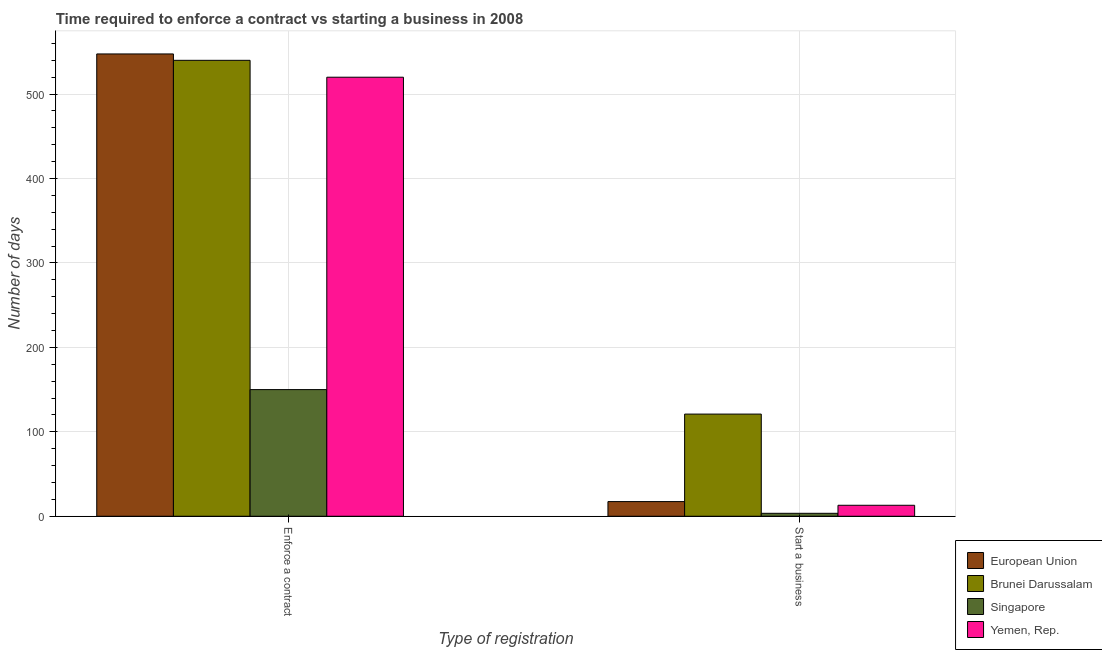How many groups of bars are there?
Keep it short and to the point. 2. Are the number of bars per tick equal to the number of legend labels?
Keep it short and to the point. Yes. What is the label of the 2nd group of bars from the left?
Your answer should be very brief. Start a business. What is the number of days to start a business in European Union?
Your answer should be very brief. 17.37. Across all countries, what is the maximum number of days to enforece a contract?
Ensure brevity in your answer.  547.56. Across all countries, what is the minimum number of days to enforece a contract?
Ensure brevity in your answer.  150. In which country was the number of days to start a business maximum?
Your response must be concise. Brunei Darussalam. In which country was the number of days to start a business minimum?
Give a very brief answer. Singapore. What is the total number of days to start a business in the graph?
Keep it short and to the point. 154.87. What is the difference between the number of days to start a business in European Union and the number of days to enforece a contract in Brunei Darussalam?
Keep it short and to the point. -522.63. What is the average number of days to enforece a contract per country?
Make the answer very short. 439.39. What is the difference between the number of days to enforece a contract and number of days to start a business in European Union?
Your answer should be compact. 530.19. In how many countries, is the number of days to start a business greater than 380 days?
Provide a short and direct response. 0. What is the ratio of the number of days to start a business in Brunei Darussalam to that in Yemen, Rep.?
Your answer should be very brief. 9.31. What does the 3rd bar from the left in Enforce a contract represents?
Your response must be concise. Singapore. Are all the bars in the graph horizontal?
Offer a terse response. No. How many countries are there in the graph?
Offer a terse response. 4. What is the difference between two consecutive major ticks on the Y-axis?
Provide a short and direct response. 100. Are the values on the major ticks of Y-axis written in scientific E-notation?
Your answer should be very brief. No. Does the graph contain any zero values?
Your answer should be very brief. No. Does the graph contain grids?
Make the answer very short. Yes. How many legend labels are there?
Make the answer very short. 4. How are the legend labels stacked?
Offer a very short reply. Vertical. What is the title of the graph?
Give a very brief answer. Time required to enforce a contract vs starting a business in 2008. Does "Tonga" appear as one of the legend labels in the graph?
Offer a very short reply. No. What is the label or title of the X-axis?
Your answer should be compact. Type of registration. What is the label or title of the Y-axis?
Make the answer very short. Number of days. What is the Number of days in European Union in Enforce a contract?
Provide a short and direct response. 547.56. What is the Number of days of Brunei Darussalam in Enforce a contract?
Provide a succinct answer. 540. What is the Number of days of Singapore in Enforce a contract?
Your answer should be compact. 150. What is the Number of days in Yemen, Rep. in Enforce a contract?
Provide a succinct answer. 520. What is the Number of days in European Union in Start a business?
Keep it short and to the point. 17.37. What is the Number of days of Brunei Darussalam in Start a business?
Your answer should be very brief. 121. What is the Number of days in Singapore in Start a business?
Provide a succinct answer. 3.5. Across all Type of registration, what is the maximum Number of days in European Union?
Your answer should be very brief. 547.56. Across all Type of registration, what is the maximum Number of days in Brunei Darussalam?
Your answer should be compact. 540. Across all Type of registration, what is the maximum Number of days of Singapore?
Provide a succinct answer. 150. Across all Type of registration, what is the maximum Number of days of Yemen, Rep.?
Ensure brevity in your answer.  520. Across all Type of registration, what is the minimum Number of days in European Union?
Provide a succinct answer. 17.37. Across all Type of registration, what is the minimum Number of days of Brunei Darussalam?
Make the answer very short. 121. Across all Type of registration, what is the minimum Number of days in Yemen, Rep.?
Your answer should be compact. 13. What is the total Number of days of European Union in the graph?
Your answer should be compact. 564.93. What is the total Number of days in Brunei Darussalam in the graph?
Your response must be concise. 661. What is the total Number of days of Singapore in the graph?
Your response must be concise. 153.5. What is the total Number of days of Yemen, Rep. in the graph?
Keep it short and to the point. 533. What is the difference between the Number of days of European Union in Enforce a contract and that in Start a business?
Ensure brevity in your answer.  530.19. What is the difference between the Number of days in Brunei Darussalam in Enforce a contract and that in Start a business?
Ensure brevity in your answer.  419. What is the difference between the Number of days in Singapore in Enforce a contract and that in Start a business?
Your response must be concise. 146.5. What is the difference between the Number of days in Yemen, Rep. in Enforce a contract and that in Start a business?
Provide a short and direct response. 507. What is the difference between the Number of days of European Union in Enforce a contract and the Number of days of Brunei Darussalam in Start a business?
Your response must be concise. 426.56. What is the difference between the Number of days of European Union in Enforce a contract and the Number of days of Singapore in Start a business?
Ensure brevity in your answer.  544.06. What is the difference between the Number of days in European Union in Enforce a contract and the Number of days in Yemen, Rep. in Start a business?
Provide a succinct answer. 534.56. What is the difference between the Number of days of Brunei Darussalam in Enforce a contract and the Number of days of Singapore in Start a business?
Ensure brevity in your answer.  536.5. What is the difference between the Number of days in Brunei Darussalam in Enforce a contract and the Number of days in Yemen, Rep. in Start a business?
Provide a short and direct response. 527. What is the difference between the Number of days in Singapore in Enforce a contract and the Number of days in Yemen, Rep. in Start a business?
Offer a terse response. 137. What is the average Number of days in European Union per Type of registration?
Your answer should be very brief. 282.46. What is the average Number of days in Brunei Darussalam per Type of registration?
Provide a succinct answer. 330.5. What is the average Number of days in Singapore per Type of registration?
Give a very brief answer. 76.75. What is the average Number of days of Yemen, Rep. per Type of registration?
Ensure brevity in your answer.  266.5. What is the difference between the Number of days of European Union and Number of days of Brunei Darussalam in Enforce a contract?
Ensure brevity in your answer.  7.56. What is the difference between the Number of days in European Union and Number of days in Singapore in Enforce a contract?
Provide a succinct answer. 397.56. What is the difference between the Number of days in European Union and Number of days in Yemen, Rep. in Enforce a contract?
Offer a very short reply. 27.56. What is the difference between the Number of days of Brunei Darussalam and Number of days of Singapore in Enforce a contract?
Provide a succinct answer. 390. What is the difference between the Number of days in Singapore and Number of days in Yemen, Rep. in Enforce a contract?
Your answer should be compact. -370. What is the difference between the Number of days in European Union and Number of days in Brunei Darussalam in Start a business?
Offer a very short reply. -103.63. What is the difference between the Number of days of European Union and Number of days of Singapore in Start a business?
Your response must be concise. 13.87. What is the difference between the Number of days in European Union and Number of days in Yemen, Rep. in Start a business?
Provide a succinct answer. 4.37. What is the difference between the Number of days of Brunei Darussalam and Number of days of Singapore in Start a business?
Offer a very short reply. 117.5. What is the difference between the Number of days in Brunei Darussalam and Number of days in Yemen, Rep. in Start a business?
Offer a very short reply. 108. What is the ratio of the Number of days of European Union in Enforce a contract to that in Start a business?
Provide a short and direct response. 31.52. What is the ratio of the Number of days of Brunei Darussalam in Enforce a contract to that in Start a business?
Make the answer very short. 4.46. What is the ratio of the Number of days of Singapore in Enforce a contract to that in Start a business?
Give a very brief answer. 42.86. What is the ratio of the Number of days of Yemen, Rep. in Enforce a contract to that in Start a business?
Ensure brevity in your answer.  40. What is the difference between the highest and the second highest Number of days in European Union?
Give a very brief answer. 530.19. What is the difference between the highest and the second highest Number of days in Brunei Darussalam?
Your response must be concise. 419. What is the difference between the highest and the second highest Number of days in Singapore?
Your answer should be very brief. 146.5. What is the difference between the highest and the second highest Number of days in Yemen, Rep.?
Offer a terse response. 507. What is the difference between the highest and the lowest Number of days of European Union?
Your answer should be compact. 530.19. What is the difference between the highest and the lowest Number of days in Brunei Darussalam?
Give a very brief answer. 419. What is the difference between the highest and the lowest Number of days of Singapore?
Your answer should be compact. 146.5. What is the difference between the highest and the lowest Number of days of Yemen, Rep.?
Make the answer very short. 507. 